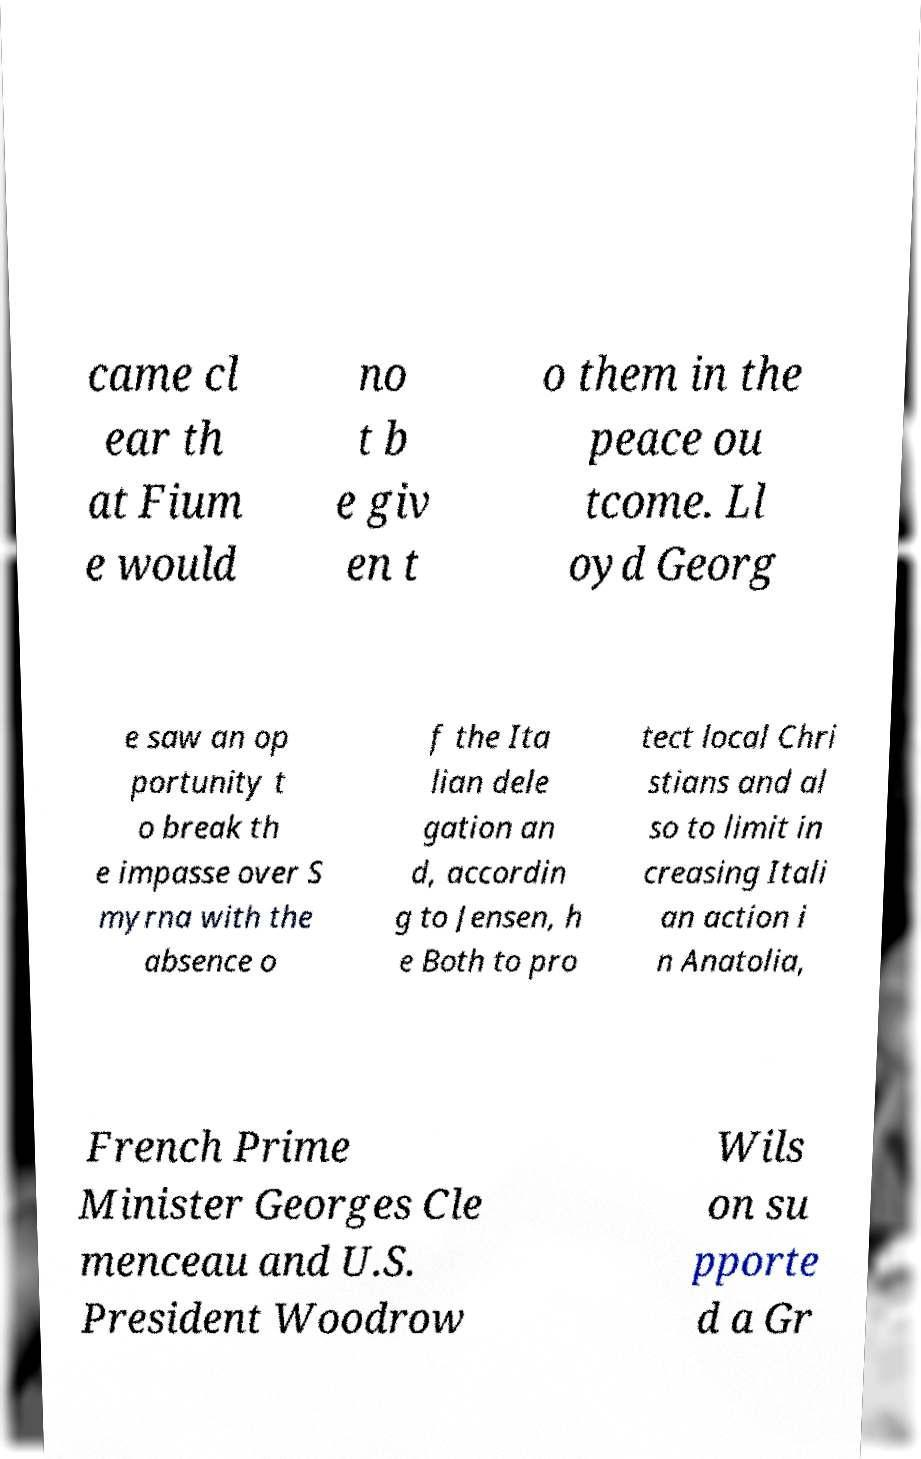Could you extract and type out the text from this image? came cl ear th at Fium e would no t b e giv en t o them in the peace ou tcome. Ll oyd Georg e saw an op portunity t o break th e impasse over S myrna with the absence o f the Ita lian dele gation an d, accordin g to Jensen, h e Both to pro tect local Chri stians and al so to limit in creasing Itali an action i n Anatolia, French Prime Minister Georges Cle menceau and U.S. President Woodrow Wils on su pporte d a Gr 